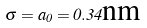Convert formula to latex. <formula><loc_0><loc_0><loc_500><loc_500>\sigma = a _ { 0 } = 0 . 3 4 \text {nm}</formula> 